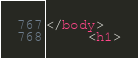<code> <loc_0><loc_0><loc_500><loc_500><_HTML_></body>
     <h1></code> 